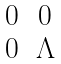Convert formula to latex. <formula><loc_0><loc_0><loc_500><loc_500>\begin{matrix} 0 & 0 \\ 0 & \Lambda \\ \end{matrix}</formula> 